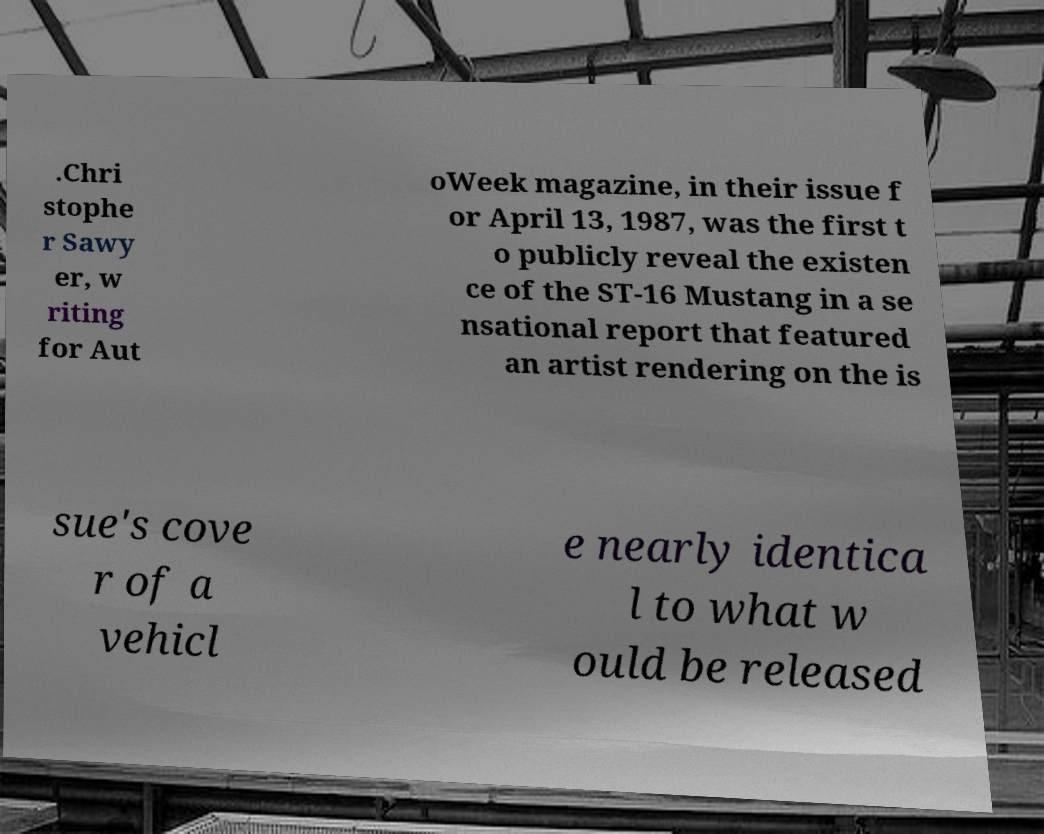Could you assist in decoding the text presented in this image and type it out clearly? .Chri stophe r Sawy er, w riting for Aut oWeek magazine, in their issue f or April 13, 1987, was the first t o publicly reveal the existen ce of the ST-16 Mustang in a se nsational report that featured an artist rendering on the is sue's cove r of a vehicl e nearly identica l to what w ould be released 